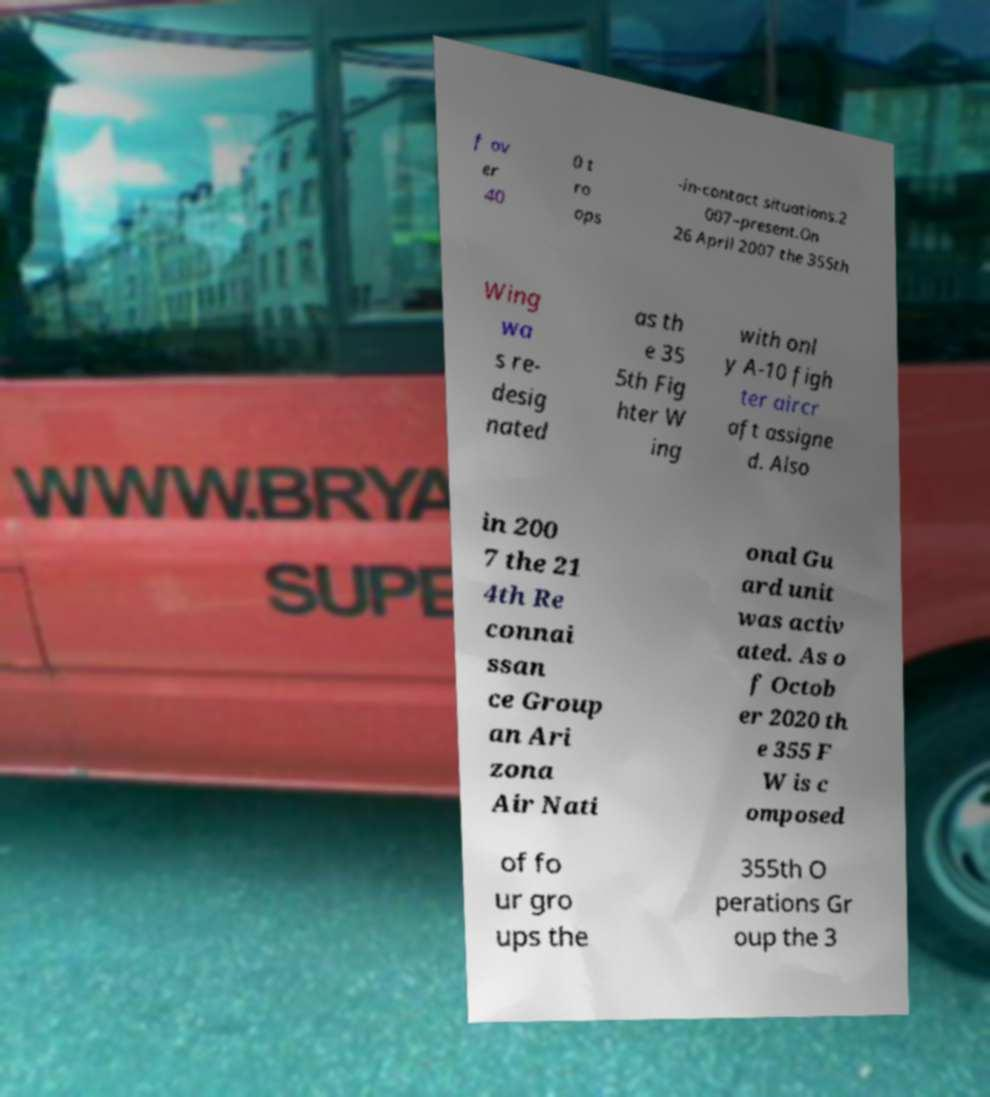There's text embedded in this image that I need extracted. Can you transcribe it verbatim? f ov er 40 0 t ro ops -in-contact situations.2 007–present.On 26 April 2007 the 355th Wing wa s re- desig nated as th e 35 5th Fig hter W ing with onl y A-10 figh ter aircr aft assigne d. Also in 200 7 the 21 4th Re connai ssan ce Group an Ari zona Air Nati onal Gu ard unit was activ ated. As o f Octob er 2020 th e 355 F W is c omposed of fo ur gro ups the 355th O perations Gr oup the 3 